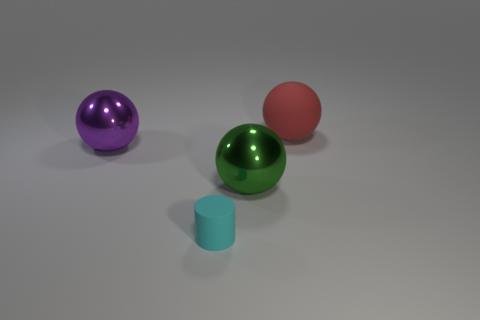Subtract 1 spheres. How many spheres are left? 2 Subtract all red rubber spheres. How many spheres are left? 2 Add 3 large cylinders. How many objects exist? 7 Subtract all red balls. How many balls are left? 2 Subtract all spheres. How many objects are left? 1 Subtract all gray spheres. Subtract all green blocks. How many spheres are left? 3 Add 2 purple metal objects. How many purple metal objects are left? 3 Add 1 small gray matte balls. How many small gray matte balls exist? 1 Subtract 0 brown cylinders. How many objects are left? 4 Subtract all large cyan shiny things. Subtract all large metallic spheres. How many objects are left? 2 